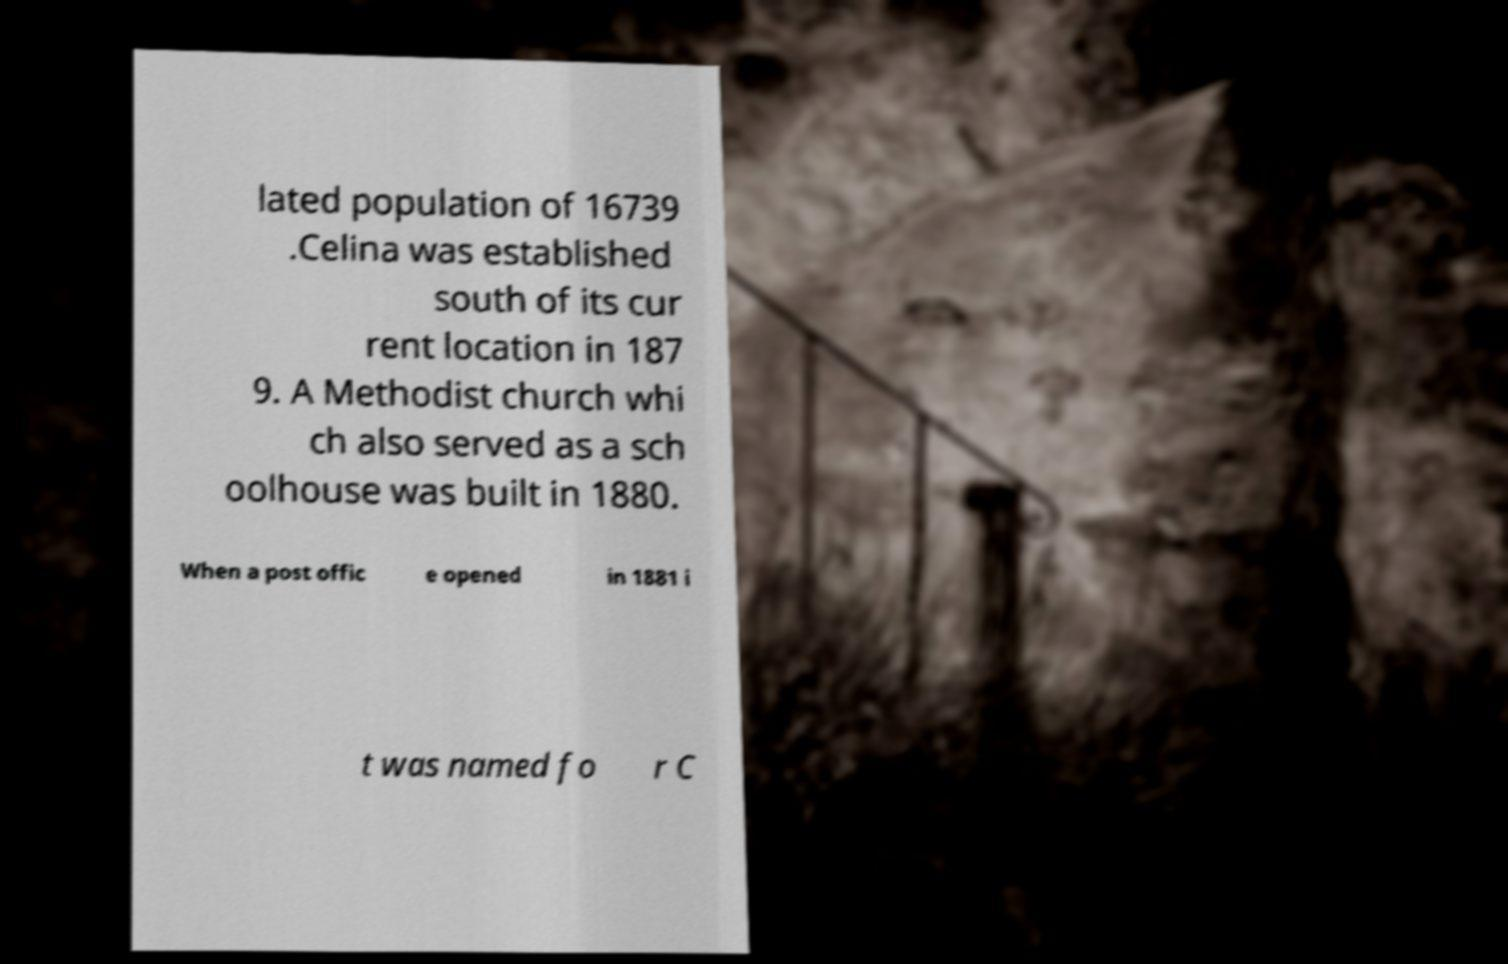What messages or text are displayed in this image? I need them in a readable, typed format. lated population of 16739 .Celina was established south of its cur rent location in 187 9. A Methodist church whi ch also served as a sch oolhouse was built in 1880. When a post offic e opened in 1881 i t was named fo r C 